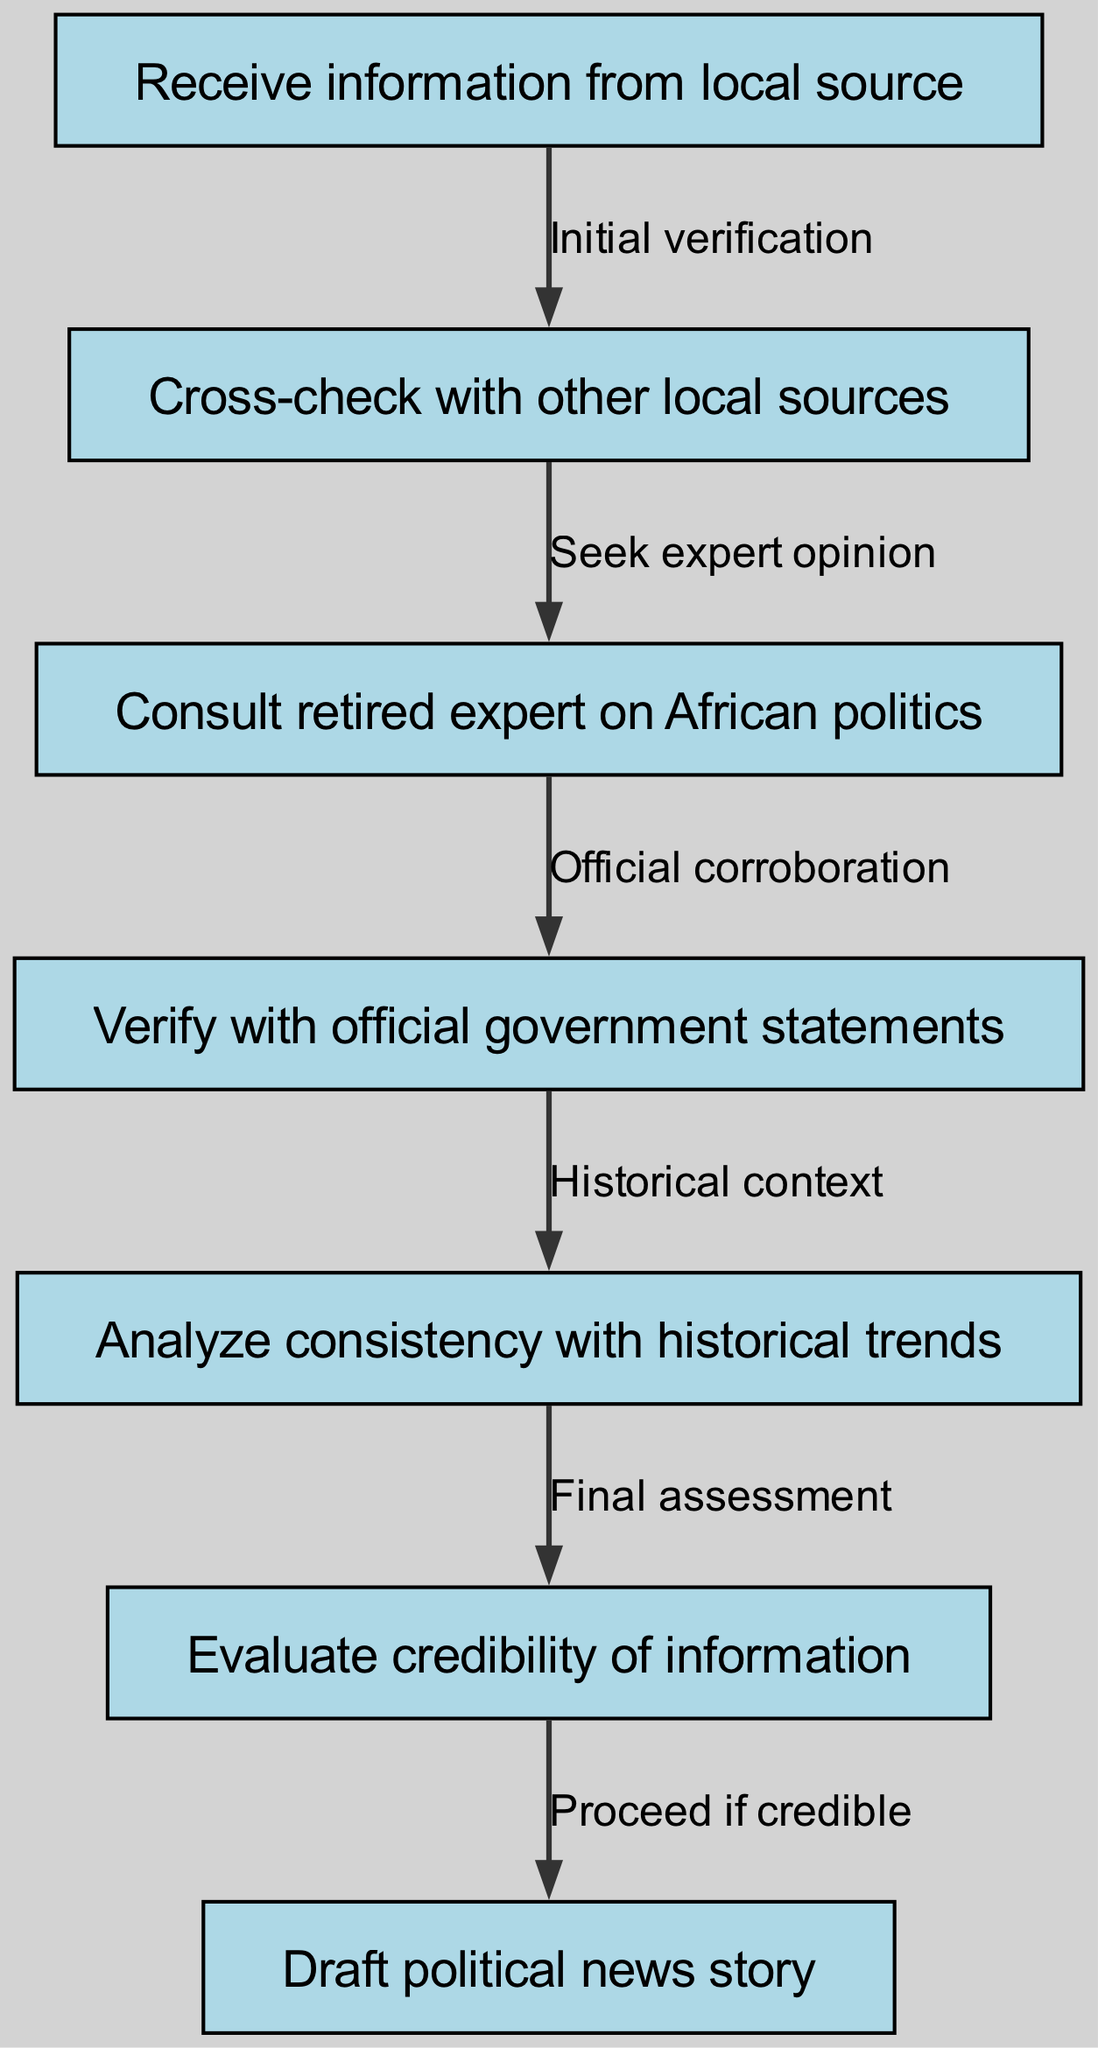What is the first step in the diagram? The diagram indicates that the first step is "Receive information from local source," as represented by the first node in the flow.
Answer: Receive information from local source How many nodes are present in the diagram? By counting the entries in the nodes section of the data provided, there are a total of seven nodes.
Answer: 7 What is the relationship between node 2 and node 3? The edge from node 2 to node 3 is labeled "Seek expert opinion," indicating the process of moving from cross-checking information to consulting with an expert.
Answer: Seek expert opinion What does node 4 verify? Node 4, represented as "Verify with official government statements," confirms the information against official sources, ensuring reliability.
Answer: Official government statements Which step involves historical context analysis? The step involving historical context is linked to node 5, indicated as "Analyze consistency with historical trends," representing the evaluation of how current information fits into historical data.
Answer: Analyze consistency with historical trends What must be evaluated before drafting the political news story? Before proceeding to draft the political news story, the step in node 6, "Evaluate credibility of information," must be completed to ensure that the information is trustworthy.
Answer: Evaluate credibility of information What is the final step in the verification process? The last node in the flow of the diagram represents the completion of the process, which is indicated as "Draft political news story," marking the culmination of all verification processes.
Answer: Draft political news story What label connects the historical context to the credibility evaluation? The edge from node 5 to node 6 is labeled "Final assessment," which indicates that after analyzing historical data, the next step is to assess the credibility of the information gathered.
Answer: Final assessment How does the process start according to the diagram? The diagram starts with the action in node 1, representing the initial point of receiving information from local sources, which initiates the verification process.
Answer: Receive information from local source 